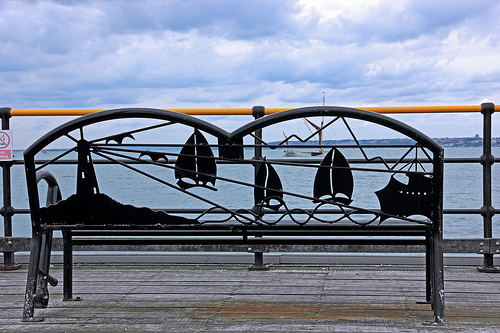<image>
Is there a bench in the water? No. The bench is not contained within the water. These objects have a different spatial relationship. 